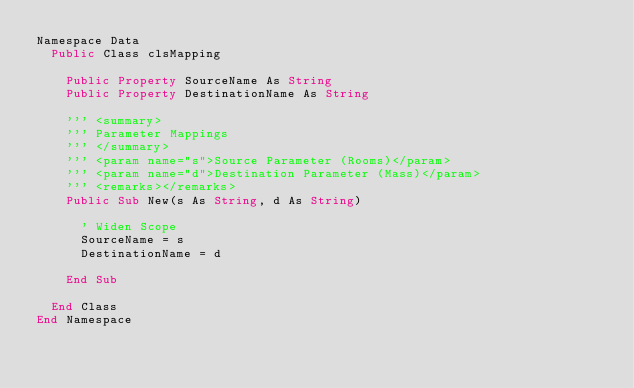<code> <loc_0><loc_0><loc_500><loc_500><_VisualBasic_>Namespace Data
  Public Class clsMapping

    Public Property SourceName As String
    Public Property DestinationName As String

    ''' <summary>
    ''' Parameter Mappings
    ''' </summary>
    ''' <param name="s">Source Parameter (Rooms)</param>
    ''' <param name="d">Destination Parameter (Mass)</param>
    ''' <remarks></remarks>
    Public Sub New(s As String, d As String)

      ' Widen Scope
      SourceName = s
      DestinationName = d

    End Sub

  End Class
End Namespace</code> 